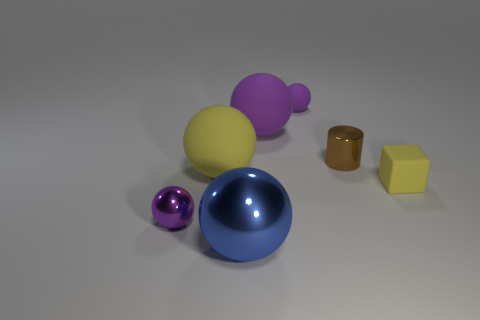Subtract all purple balls. How many were subtracted if there are1purple balls left? 2 Subtract all cyan blocks. How many purple balls are left? 3 Subtract all cyan balls. Subtract all gray cubes. How many balls are left? 5 Add 2 yellow spheres. How many objects exist? 9 Subtract all spheres. How many objects are left? 2 Add 3 big shiny blocks. How many big shiny blocks exist? 3 Subtract 0 brown spheres. How many objects are left? 7 Subtract all large matte objects. Subtract all tiny brown things. How many objects are left? 4 Add 3 big rubber things. How many big rubber things are left? 5 